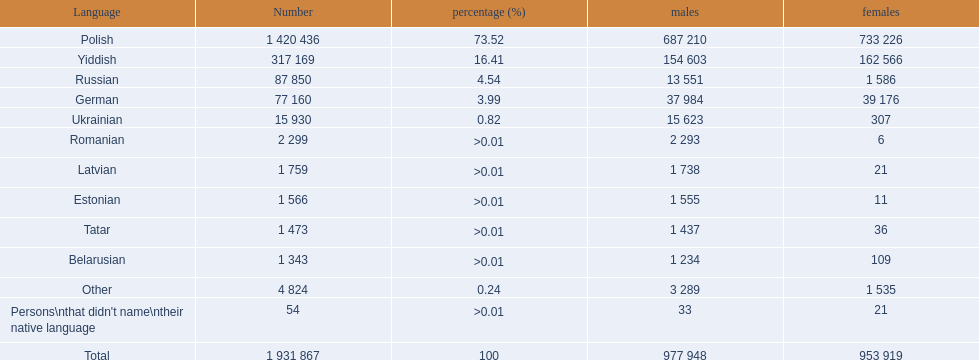What named native languages spoken in the warsaw governorate have more males then females? Russian, Ukrainian, Romanian, Latvian, Estonian, Tatar, Belarusian. Which of those have less then 500 males listed? Romanian, Latvian, Estonian, Tatar, Belarusian. Of the remaining languages which of them have less then 20 females? Romanian, Estonian. Which of these has the highest total number listed? Romanian. 